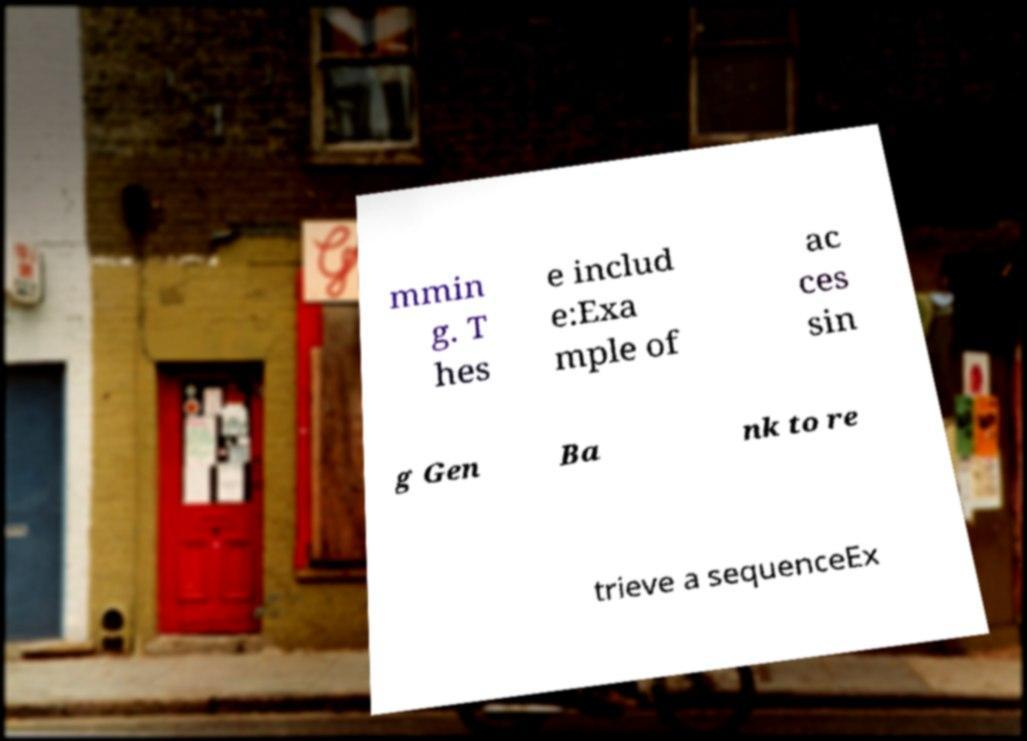I need the written content from this picture converted into text. Can you do that? mmin g. T hes e includ e:Exa mple of ac ces sin g Gen Ba nk to re trieve a sequenceEx 